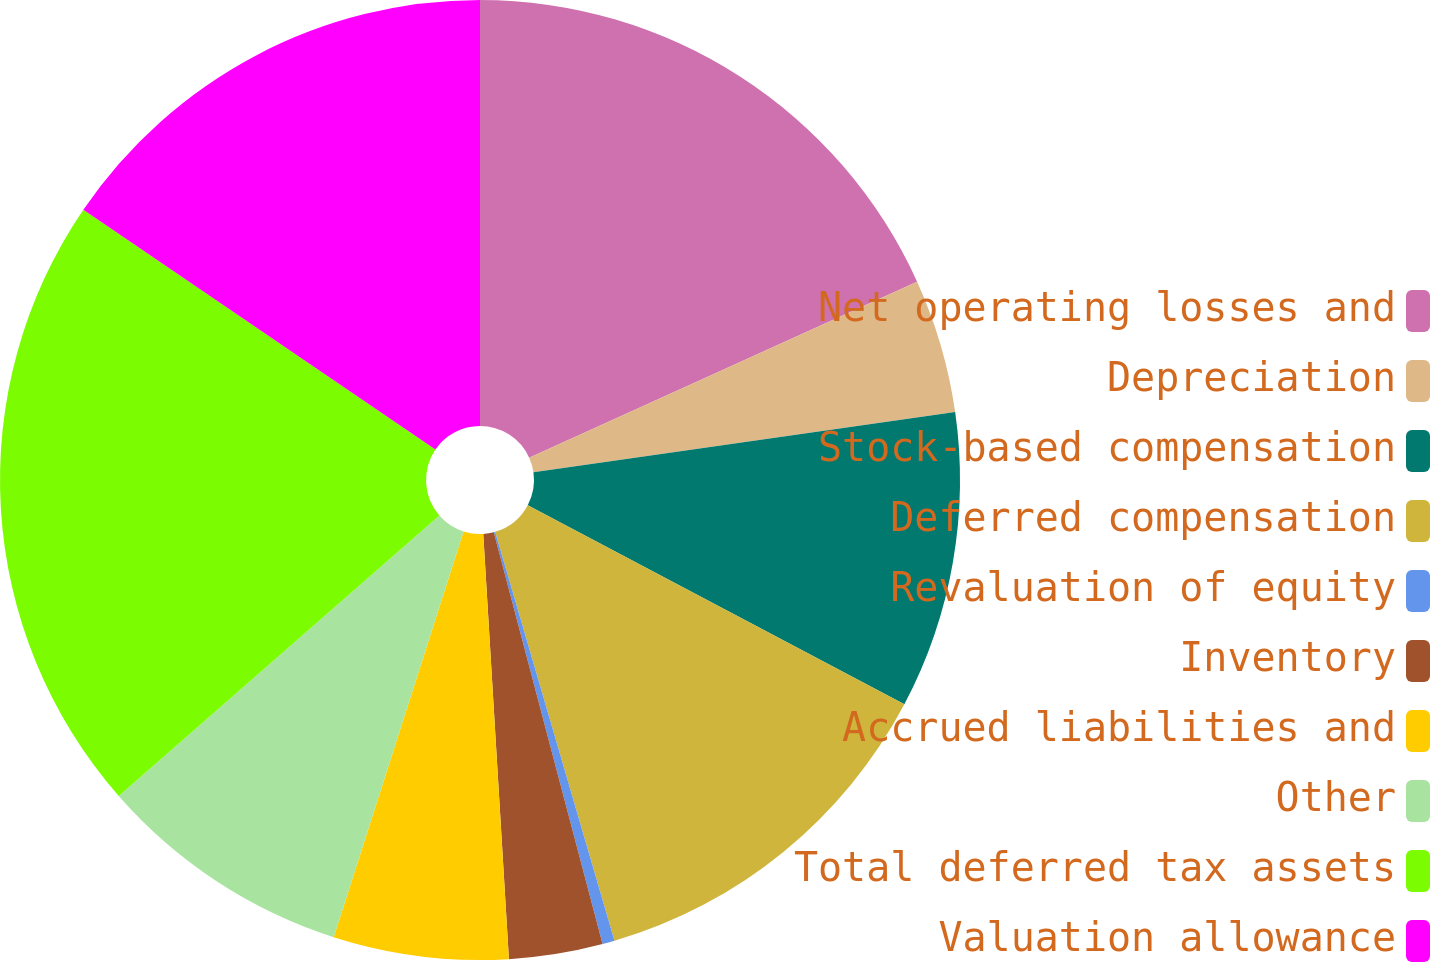Convert chart to OTSL. <chart><loc_0><loc_0><loc_500><loc_500><pie_chart><fcel>Net operating losses and<fcel>Depreciation<fcel>Stock-based compensation<fcel>Deferred compensation<fcel>Revaluation of equity<fcel>Inventory<fcel>Accrued liabilities and<fcel>Other<fcel>Total deferred tax assets<fcel>Valuation allowance<nl><fcel>18.22%<fcel>4.52%<fcel>10.0%<fcel>12.74%<fcel>0.41%<fcel>3.15%<fcel>5.89%<fcel>8.63%<fcel>20.96%<fcel>15.48%<nl></chart> 